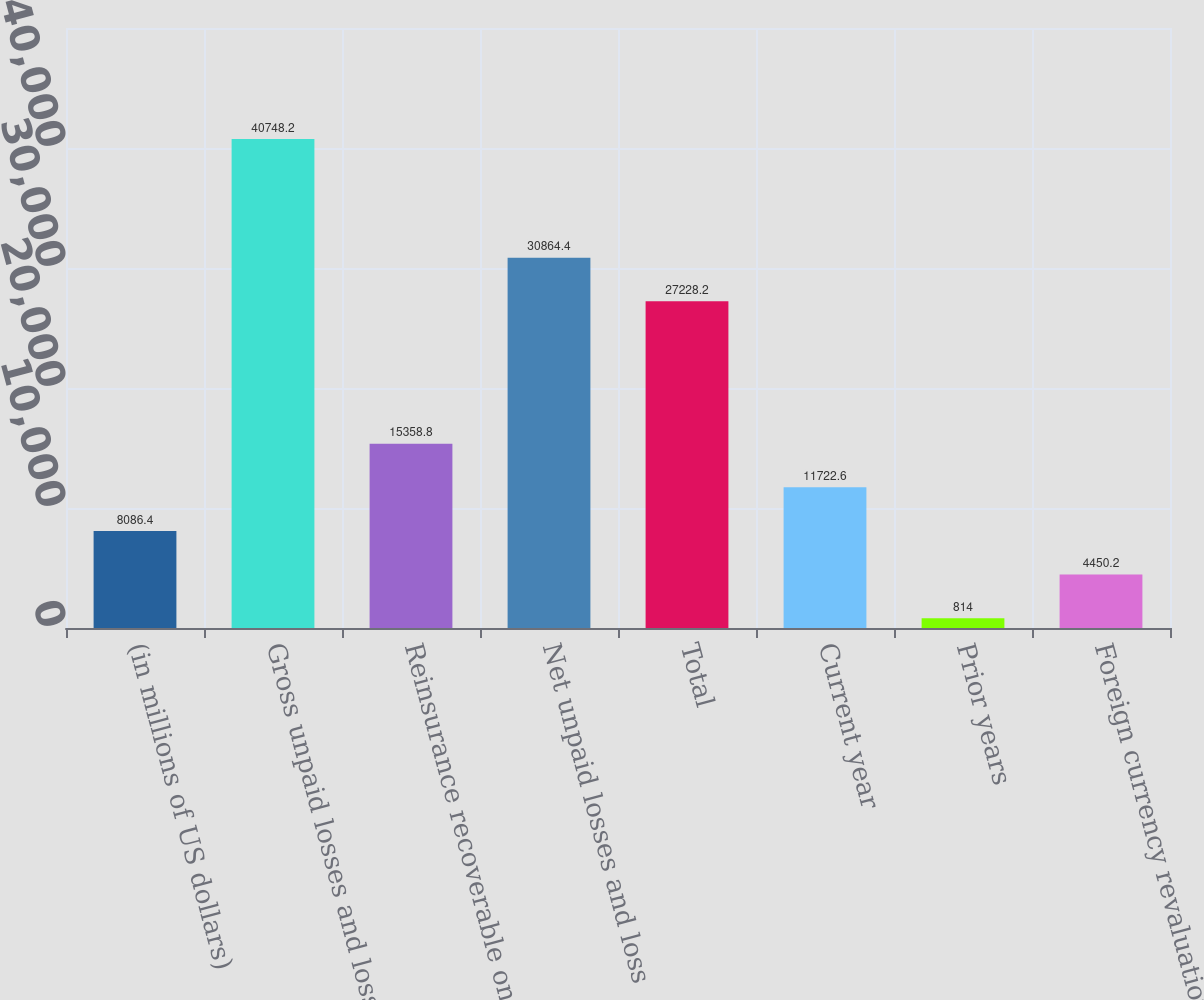<chart> <loc_0><loc_0><loc_500><loc_500><bar_chart><fcel>(in millions of US dollars)<fcel>Gross unpaid losses and loss<fcel>Reinsurance recoverable on<fcel>Net unpaid losses and loss<fcel>Total<fcel>Current year<fcel>Prior years<fcel>Foreign currency revaluation<nl><fcel>8086.4<fcel>40748.2<fcel>15358.8<fcel>30864.4<fcel>27228.2<fcel>11722.6<fcel>814<fcel>4450.2<nl></chart> 